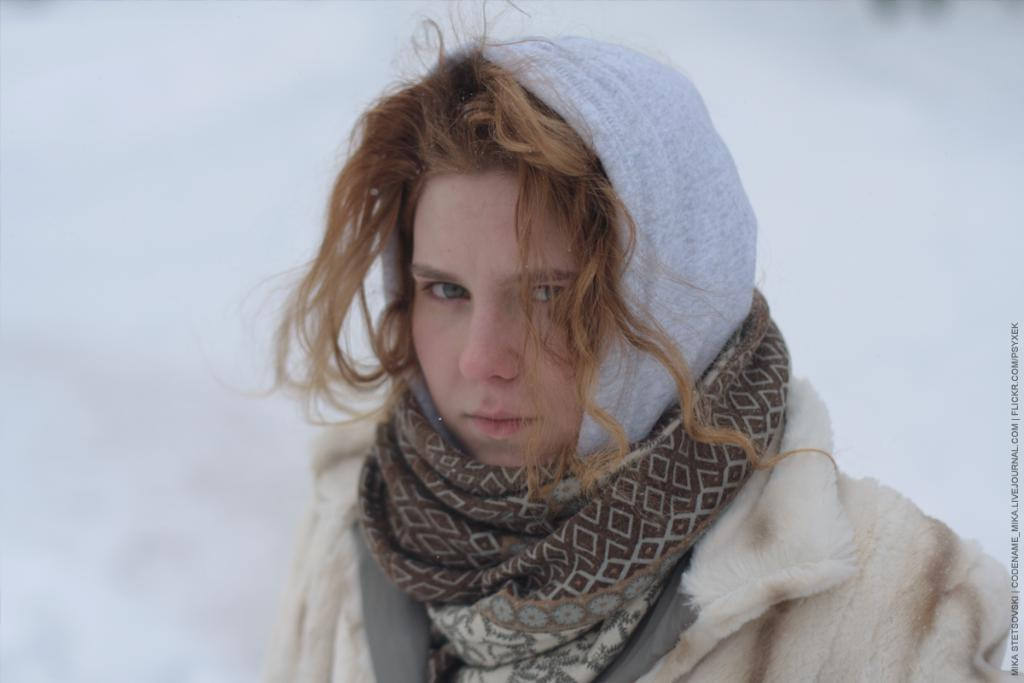Who is the main subject in the center of the picture? There is a woman in the center of the picture. What is the woman wearing in the image? The woman is wearing a jacket and a scarf. Can you describe the background of the image? The background of the image is blurred. What day of the week is depicted in the image? The day of the week is not depicted in the image; it is a still photograph and does not show any specific day. 